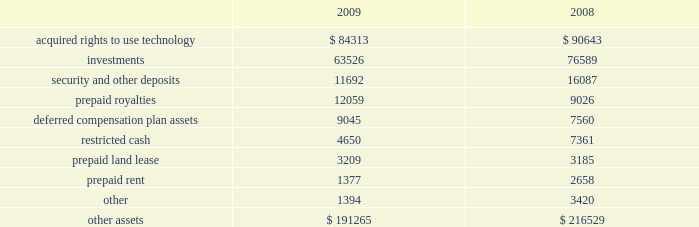Adobe systems incorporated notes to consolidated financial statements ( continued ) note 8 .
Other assets other assets as of november 27 , 2009 and november 28 , 2008 consisted of the following ( in thousands ) : .
Acquired rights to use technology purchased during fiscal 2009 and fiscal 2008 was $ 6.0 million and $ 100.4 million , respectively .
Of the cost for fiscal 2008 , an estimated $ 56.4 million was related to future licensing rights and has been capitalized and is being amortized on a straight-line basis over the estimated useful lives up to fifteen years .
Of the remaining costs for fiscal 2008 , we estimated that $ 27.2 million was related to historical use of licensing rights which was expensed as cost of sales and the residual of $ 16.8 million for fiscal 2008 was expensed as general and administrative costs .
In connection with these licensing arrangements , we have the ability to acquire additional rights to use technology in the future .
See note 17 for further information regarding our contractual commitments .
In general , acquired rights to use technology are amortized over their estimated useful lives of 3 to 15 years .
Included in investments are our indirect investments through our limited partnership interest in adobe ventures of approximately $ 37.1 million and $ 39.0 million as of november 27 , 2009 and november 28 , 2008 , respectively , which is consolidated in accordance with the provisions for consolidating variable interest entities .
The partnership is controlled by granite ventures , an independent venture capital firm and sole general partner of adobe ventures .
We are the primary beneficiary of adobe ventures and bear virtually all of the risks and rewards related to our ownership .
Our investment in adobe ventures does not have a significant impact on our consolidated financial position , results of operations or cash flows .
Adobe ventures carries its investments in equity securities at estimated fair value and investment gains and losses are included in our consolidated statements of income .
Substantially all of the investments held by adobe ventures at november 27 , 2009 and november 28 , 2008 are not publicly traded and , therefore , there is no established market for these securities .
In order to determine the fair value of these investments , we use the most recent round of financing involving new non-strategic investors or estimates of current market value made by granite ventures .
It is our policy to evaluate the fair value of these investments held by adobe ventures , as well as our direct investments , on a regular basis .
This evaluation includes , but is not limited to , reviewing each company 2019s cash position , financing needs , earnings and revenue outlook , operational performance , management and ownership changes and competition .
In the case of privately-held companies , this evaluation is based on information that we request from these companies .
This information is not subject to the same disclosure regulations as u.s .
Publicly traded companies and as such , the basis for these evaluations is subject to the timing and the accuracy of the data received from these companies .
See note 4 for further information regarding adobe ventures .
Also included in investments are our direct investments in privately-held companies of approximately $ 26.4 million and $ 37.6 million as of november 27 , 2009 and november 28 , 2008 , respectively , which are accounted for based on the cost method .
We assess these investments for impairment in value as circumstances dictate .
See note 4 for further information regarding our cost method investments .
We entered into a purchase and sale agreement , effective may 12 , 2008 , for the acquisition of real property located in waltham , massachusetts .
We purchased the property upon completion of construction of an office building shell and core , parking structure , and site improvements .
The purchase price for the property was $ 44.7 million and closed on june 16 , 2009 .
We made an initial deposit of $ 7.0 million which was included in security and other deposits as of november 28 , 2008 and the remaining balance was paid at closing .
This deposit was held in escrow until closing and then applied to the purchase price. .
What is the growth rate in the other assets from 2008 to 2009? 
Computations: ((191265 - 216529) / 216529)
Answer: -0.11668. 